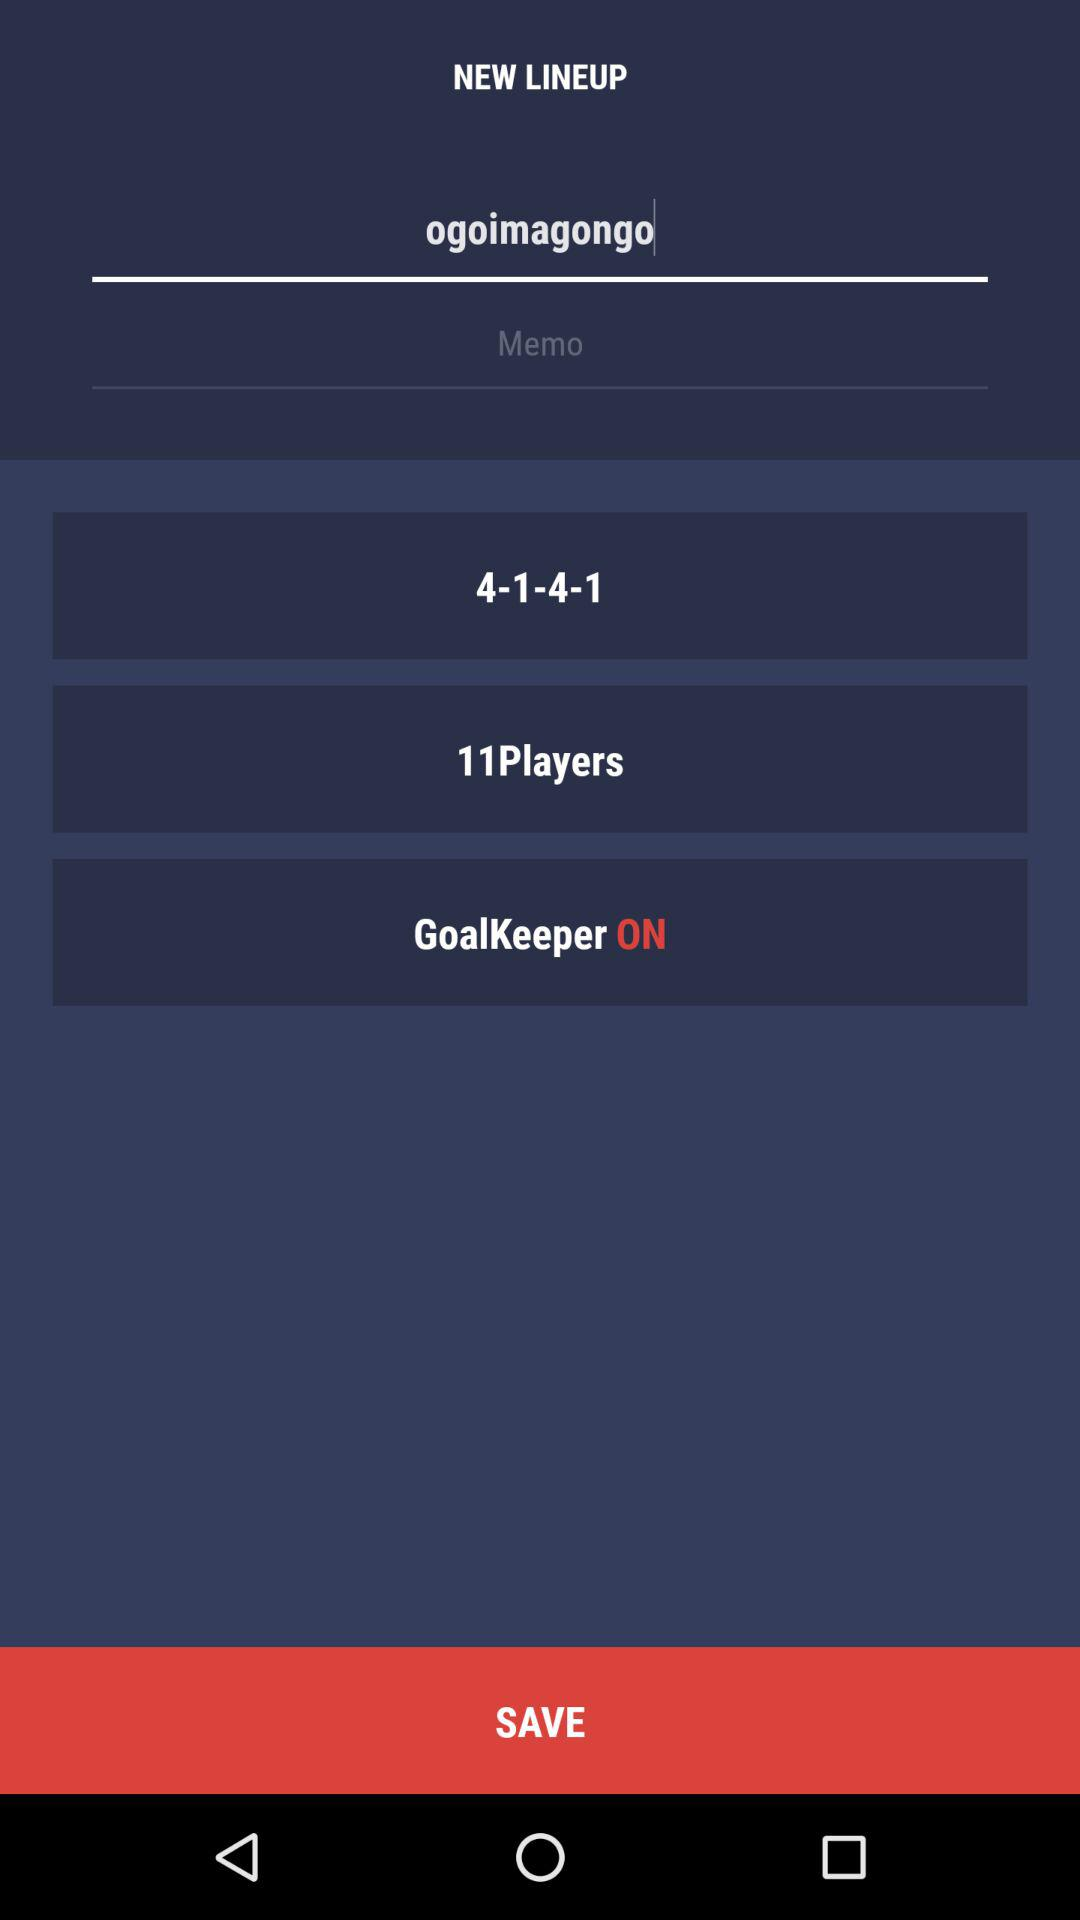What is the number of players? The number of players is 11. 